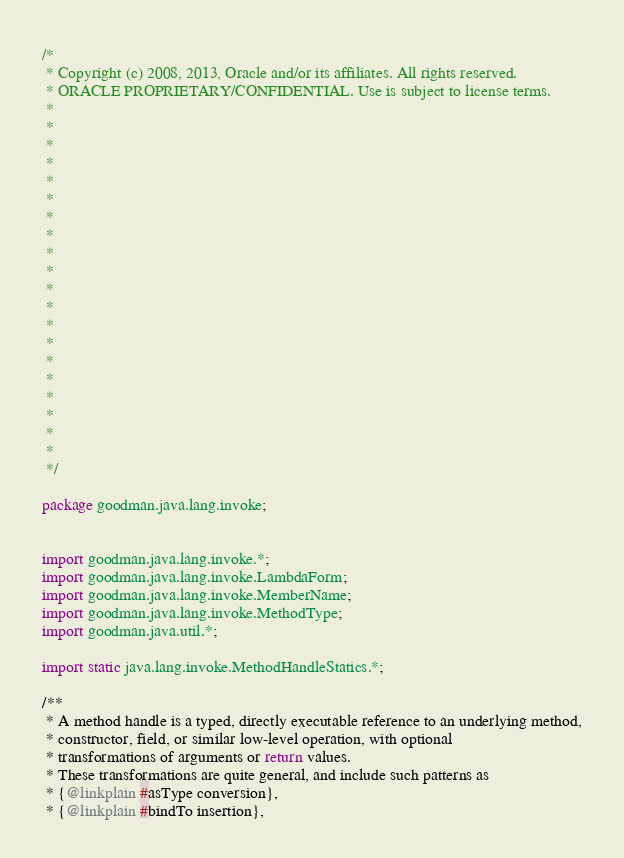<code> <loc_0><loc_0><loc_500><loc_500><_Java_>/*
 * Copyright (c) 2008, 2013, Oracle and/or its affiliates. All rights reserved.
 * ORACLE PROPRIETARY/CONFIDENTIAL. Use is subject to license terms.
 *
 *
 *
 *
 *
 *
 *
 *
 *
 *
 *
 *
 *
 *
 *
 *
 *
 *
 *
 *
 */

package goodman.java.lang.invoke;


import goodman.java.lang.invoke.*;
import goodman.java.lang.invoke.LambdaForm;
import goodman.java.lang.invoke.MemberName;
import goodman.java.lang.invoke.MethodType;
import goodman.java.util.*;

import static java.lang.invoke.MethodHandleStatics.*;

/**
 * A method handle is a typed, directly executable reference to an underlying method,
 * constructor, field, or similar low-level operation, with optional
 * transformations of arguments or return values.
 * These transformations are quite general, and include such patterns as
 * {@linkplain #asType conversion},
 * {@linkplain #bindTo insertion},</code> 